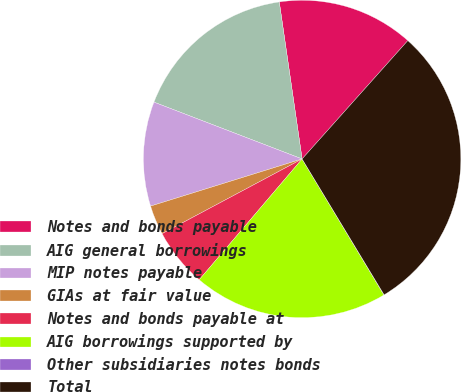<chart> <loc_0><loc_0><loc_500><loc_500><pie_chart><fcel>Notes and bonds payable<fcel>AIG general borrowings<fcel>MIP notes payable<fcel>GIAs at fair value<fcel>Notes and bonds payable at<fcel>AIG borrowings supported by<fcel>Other subsidiaries notes bonds<fcel>Total<nl><fcel>13.9%<fcel>16.87%<fcel>10.63%<fcel>3.0%<fcel>5.97%<fcel>19.85%<fcel>0.02%<fcel>29.75%<nl></chart> 